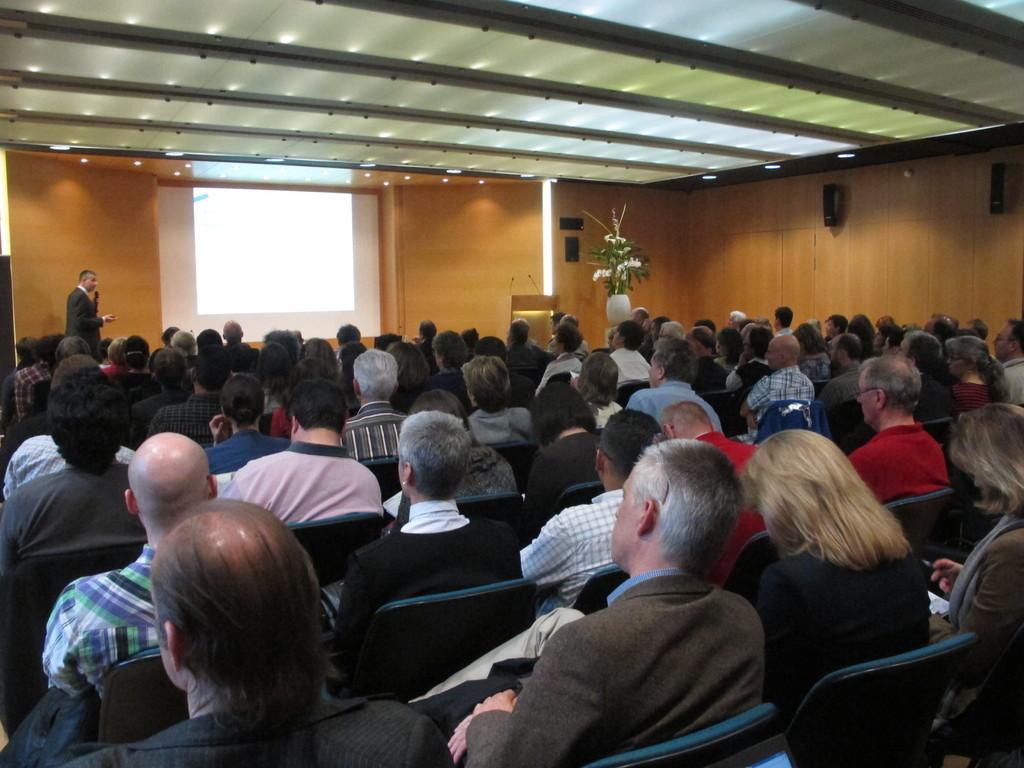Could you give a brief overview of what you see in this image? In this image it seems like it is a seminar hall in which there are so many people sitting in the chairs. In the background there is a screen in the middle. At the top there is ceiling with the lights. On the left side there is a man standing on the stage by holding the mic. On the right side there is a flower vase near the podium. On the podium there are two mics. On the right side there are speakers to the wall. 